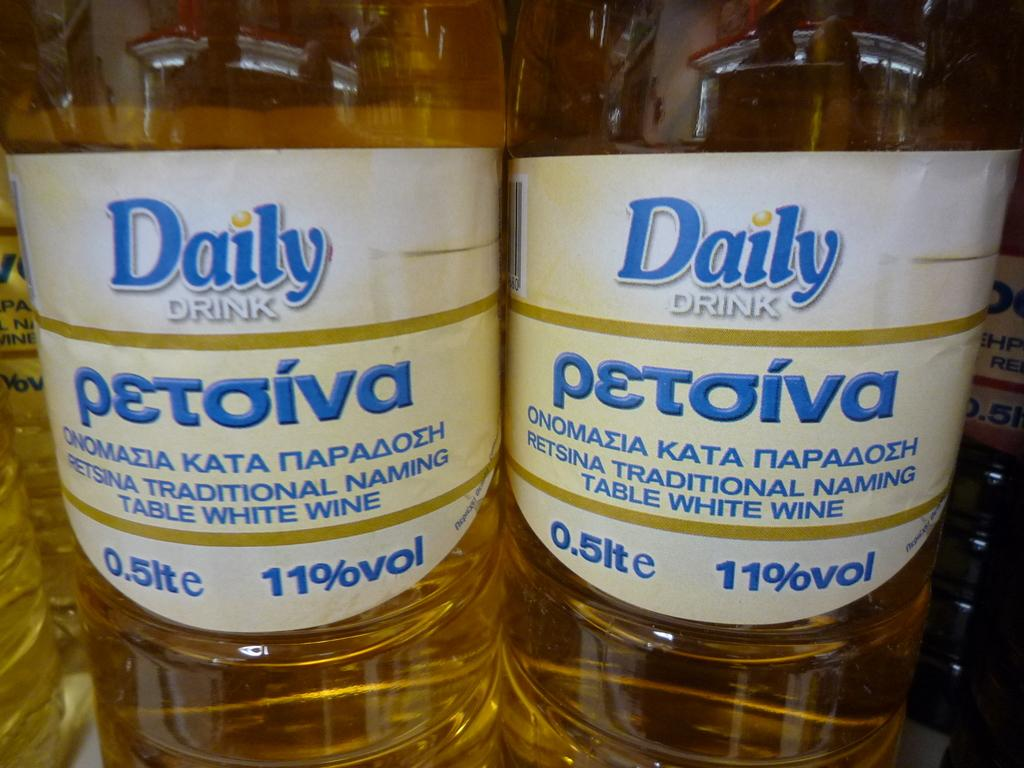<image>
Write a terse but informative summary of the picture. Two bottles of Daily Drink next to one another. 